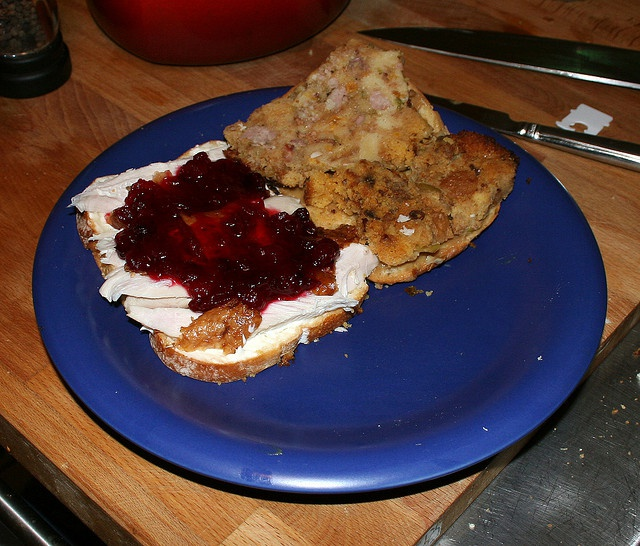Describe the objects in this image and their specific colors. I can see sandwich in black, brown, maroon, and lightgray tones, knife in black, maroon, gray, and white tones, bottle in black, maroon, and gray tones, and knife in black, maroon, and gray tones in this image. 